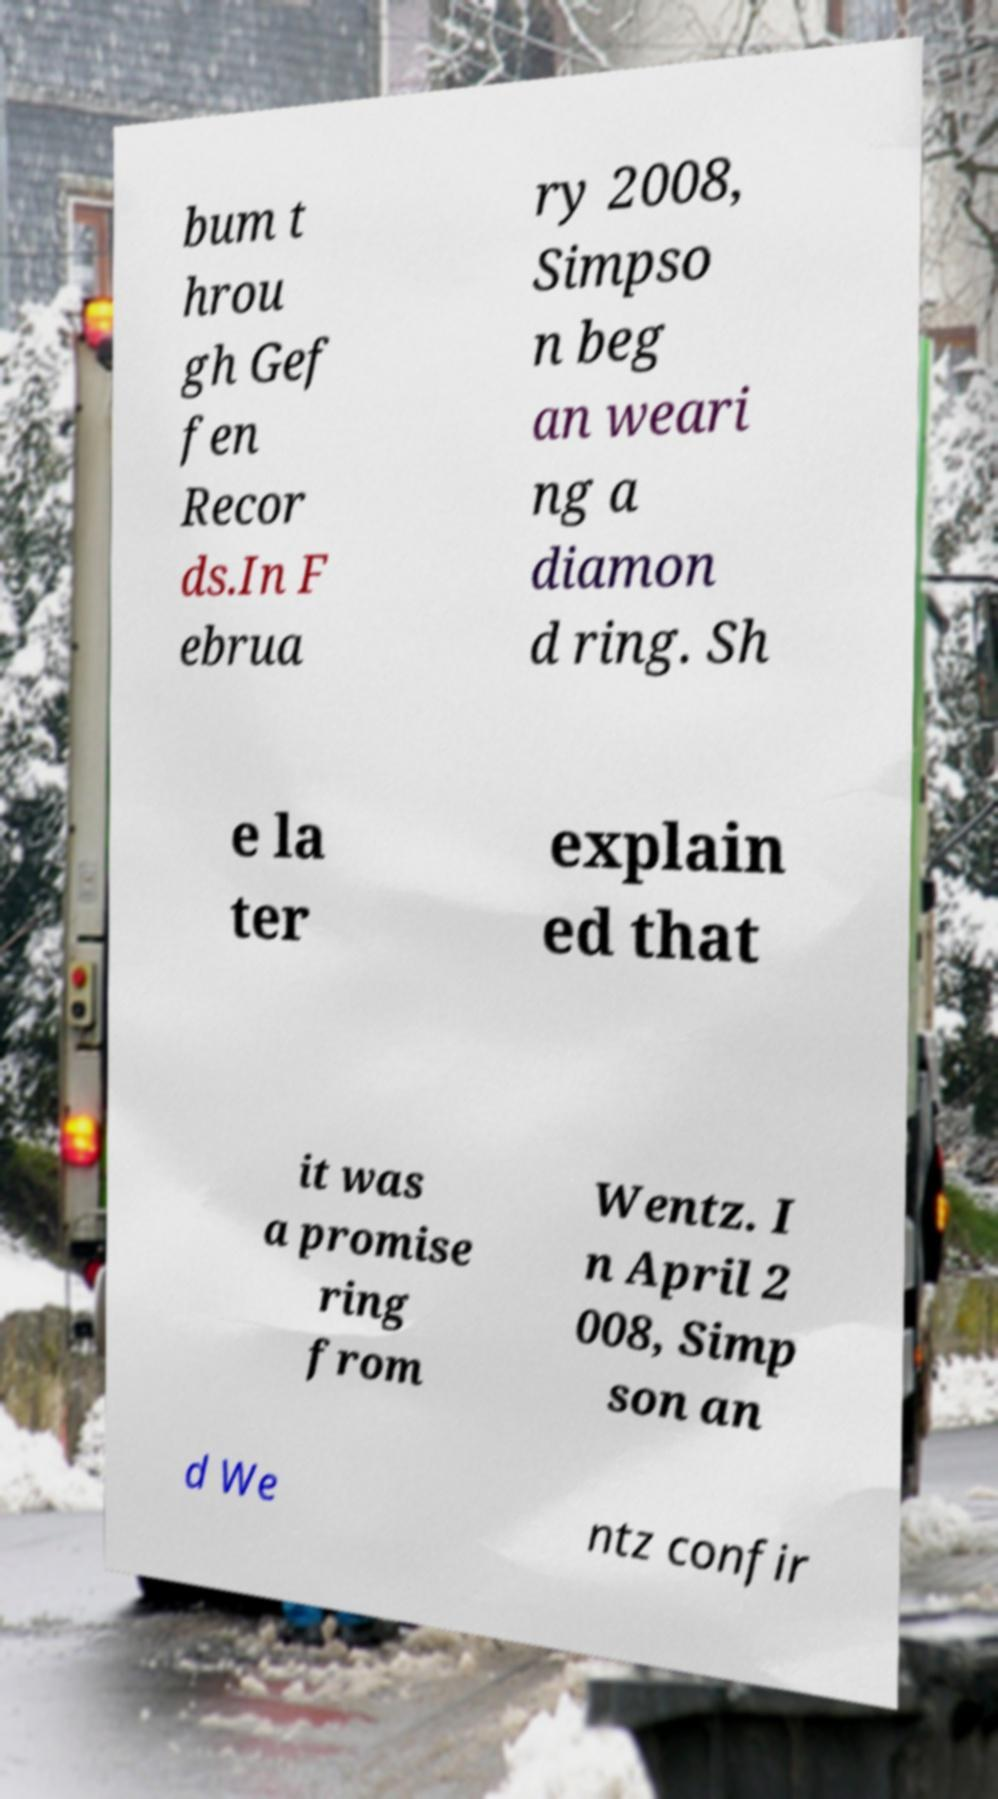Can you read and provide the text displayed in the image?This photo seems to have some interesting text. Can you extract and type it out for me? bum t hrou gh Gef fen Recor ds.In F ebrua ry 2008, Simpso n beg an weari ng a diamon d ring. Sh e la ter explain ed that it was a promise ring from Wentz. I n April 2 008, Simp son an d We ntz confir 